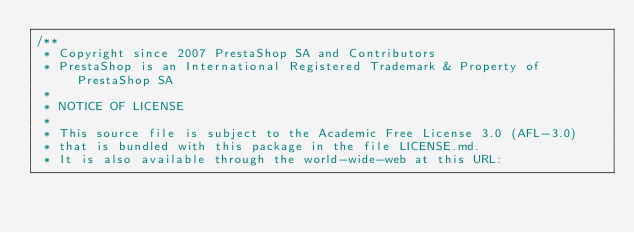Convert code to text. <code><loc_0><loc_0><loc_500><loc_500><_JavaScript_>/**
 * Copyright since 2007 PrestaShop SA and Contributors
 * PrestaShop is an International Registered Trademark & Property of PrestaShop SA
 *
 * NOTICE OF LICENSE
 *
 * This source file is subject to the Academic Free License 3.0 (AFL-3.0)
 * that is bundled with this package in the file LICENSE.md.
 * It is also available through the world-wide-web at this URL:</code> 